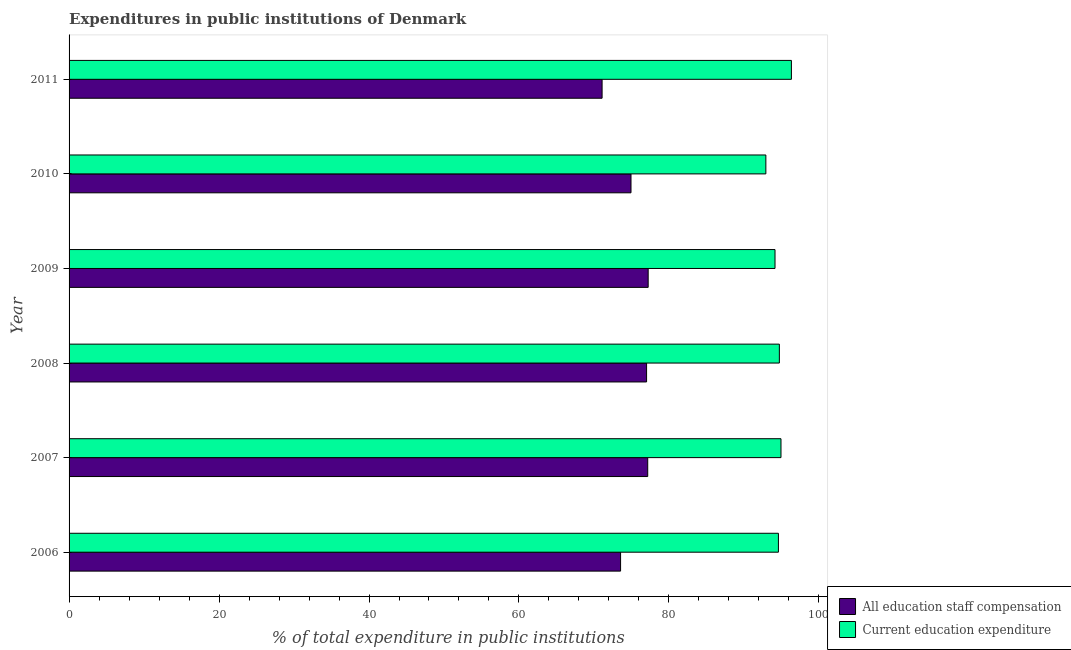How many different coloured bars are there?
Give a very brief answer. 2. How many groups of bars are there?
Provide a short and direct response. 6. How many bars are there on the 5th tick from the top?
Keep it short and to the point. 2. What is the label of the 5th group of bars from the top?
Give a very brief answer. 2007. What is the expenditure in staff compensation in 2008?
Offer a very short reply. 77.02. Across all years, what is the maximum expenditure in staff compensation?
Your response must be concise. 77.23. Across all years, what is the minimum expenditure in education?
Offer a terse response. 92.93. In which year was the expenditure in education maximum?
Provide a succinct answer. 2011. In which year was the expenditure in staff compensation minimum?
Ensure brevity in your answer.  2011. What is the total expenditure in staff compensation in the graph?
Offer a very short reply. 451. What is the difference between the expenditure in staff compensation in 2008 and that in 2010?
Your answer should be compact. 2.08. What is the difference between the expenditure in staff compensation in 2009 and the expenditure in education in 2010?
Offer a terse response. -15.69. What is the average expenditure in staff compensation per year?
Your answer should be very brief. 75.17. In the year 2006, what is the difference between the expenditure in education and expenditure in staff compensation?
Offer a terse response. 21.05. In how many years, is the expenditure in staff compensation greater than 96 %?
Your answer should be very brief. 0. What is the ratio of the expenditure in education in 2007 to that in 2009?
Your response must be concise. 1.01. What is the difference between the highest and the second highest expenditure in education?
Your answer should be compact. 1.39. What is the difference between the highest and the lowest expenditure in staff compensation?
Offer a very short reply. 6.15. Is the sum of the expenditure in education in 2007 and 2010 greater than the maximum expenditure in staff compensation across all years?
Your answer should be very brief. Yes. What does the 2nd bar from the top in 2008 represents?
Ensure brevity in your answer.  All education staff compensation. What does the 1st bar from the bottom in 2009 represents?
Your answer should be very brief. All education staff compensation. How many bars are there?
Offer a very short reply. 12. Are all the bars in the graph horizontal?
Provide a short and direct response. Yes. How many years are there in the graph?
Make the answer very short. 6. What is the difference between two consecutive major ticks on the X-axis?
Give a very brief answer. 20. Does the graph contain any zero values?
Your answer should be compact. No. Does the graph contain grids?
Ensure brevity in your answer.  No. How are the legend labels stacked?
Provide a short and direct response. Vertical. What is the title of the graph?
Your answer should be very brief. Expenditures in public institutions of Denmark. What is the label or title of the X-axis?
Your answer should be very brief. % of total expenditure in public institutions. What is the label or title of the Y-axis?
Provide a short and direct response. Year. What is the % of total expenditure in public institutions of All education staff compensation in 2006?
Ensure brevity in your answer.  73.55. What is the % of total expenditure in public institutions in Current education expenditure in 2006?
Your answer should be compact. 94.6. What is the % of total expenditure in public institutions of All education staff compensation in 2007?
Provide a short and direct response. 77.17. What is the % of total expenditure in public institutions in Current education expenditure in 2007?
Make the answer very short. 94.94. What is the % of total expenditure in public institutions in All education staff compensation in 2008?
Your answer should be compact. 77.02. What is the % of total expenditure in public institutions of Current education expenditure in 2008?
Provide a short and direct response. 94.73. What is the % of total expenditure in public institutions of All education staff compensation in 2009?
Keep it short and to the point. 77.23. What is the % of total expenditure in public institutions in Current education expenditure in 2009?
Keep it short and to the point. 94.15. What is the % of total expenditure in public institutions of All education staff compensation in 2010?
Offer a very short reply. 74.94. What is the % of total expenditure in public institutions in Current education expenditure in 2010?
Keep it short and to the point. 92.93. What is the % of total expenditure in public institutions in All education staff compensation in 2011?
Offer a terse response. 71.09. What is the % of total expenditure in public institutions of Current education expenditure in 2011?
Your response must be concise. 96.33. Across all years, what is the maximum % of total expenditure in public institutions of All education staff compensation?
Provide a succinct answer. 77.23. Across all years, what is the maximum % of total expenditure in public institutions of Current education expenditure?
Offer a terse response. 96.33. Across all years, what is the minimum % of total expenditure in public institutions in All education staff compensation?
Offer a terse response. 71.09. Across all years, what is the minimum % of total expenditure in public institutions of Current education expenditure?
Make the answer very short. 92.93. What is the total % of total expenditure in public institutions of All education staff compensation in the graph?
Make the answer very short. 451. What is the total % of total expenditure in public institutions of Current education expenditure in the graph?
Make the answer very short. 567.68. What is the difference between the % of total expenditure in public institutions of All education staff compensation in 2006 and that in 2007?
Your answer should be very brief. -3.62. What is the difference between the % of total expenditure in public institutions of Current education expenditure in 2006 and that in 2007?
Your answer should be very brief. -0.34. What is the difference between the % of total expenditure in public institutions of All education staff compensation in 2006 and that in 2008?
Provide a short and direct response. -3.47. What is the difference between the % of total expenditure in public institutions in Current education expenditure in 2006 and that in 2008?
Keep it short and to the point. -0.13. What is the difference between the % of total expenditure in public institutions of All education staff compensation in 2006 and that in 2009?
Your response must be concise. -3.68. What is the difference between the % of total expenditure in public institutions of Current education expenditure in 2006 and that in 2009?
Ensure brevity in your answer.  0.45. What is the difference between the % of total expenditure in public institutions of All education staff compensation in 2006 and that in 2010?
Provide a succinct answer. -1.39. What is the difference between the % of total expenditure in public institutions of Current education expenditure in 2006 and that in 2010?
Your answer should be very brief. 1.67. What is the difference between the % of total expenditure in public institutions of All education staff compensation in 2006 and that in 2011?
Your answer should be compact. 2.47. What is the difference between the % of total expenditure in public institutions in Current education expenditure in 2006 and that in 2011?
Offer a terse response. -1.73. What is the difference between the % of total expenditure in public institutions of All education staff compensation in 2007 and that in 2008?
Offer a very short reply. 0.15. What is the difference between the % of total expenditure in public institutions of Current education expenditure in 2007 and that in 2008?
Provide a succinct answer. 0.22. What is the difference between the % of total expenditure in public institutions in All education staff compensation in 2007 and that in 2009?
Keep it short and to the point. -0.06. What is the difference between the % of total expenditure in public institutions of Current education expenditure in 2007 and that in 2009?
Ensure brevity in your answer.  0.8. What is the difference between the % of total expenditure in public institutions of All education staff compensation in 2007 and that in 2010?
Your answer should be compact. 2.23. What is the difference between the % of total expenditure in public institutions in Current education expenditure in 2007 and that in 2010?
Provide a short and direct response. 2.02. What is the difference between the % of total expenditure in public institutions in All education staff compensation in 2007 and that in 2011?
Your answer should be compact. 6.08. What is the difference between the % of total expenditure in public institutions of Current education expenditure in 2007 and that in 2011?
Offer a very short reply. -1.39. What is the difference between the % of total expenditure in public institutions in All education staff compensation in 2008 and that in 2009?
Offer a terse response. -0.21. What is the difference between the % of total expenditure in public institutions of Current education expenditure in 2008 and that in 2009?
Your answer should be compact. 0.58. What is the difference between the % of total expenditure in public institutions of All education staff compensation in 2008 and that in 2010?
Offer a very short reply. 2.08. What is the difference between the % of total expenditure in public institutions in Current education expenditure in 2008 and that in 2010?
Offer a very short reply. 1.8. What is the difference between the % of total expenditure in public institutions of All education staff compensation in 2008 and that in 2011?
Offer a terse response. 5.93. What is the difference between the % of total expenditure in public institutions in Current education expenditure in 2008 and that in 2011?
Provide a short and direct response. -1.61. What is the difference between the % of total expenditure in public institutions of All education staff compensation in 2009 and that in 2010?
Make the answer very short. 2.29. What is the difference between the % of total expenditure in public institutions of Current education expenditure in 2009 and that in 2010?
Ensure brevity in your answer.  1.22. What is the difference between the % of total expenditure in public institutions in All education staff compensation in 2009 and that in 2011?
Give a very brief answer. 6.15. What is the difference between the % of total expenditure in public institutions in Current education expenditure in 2009 and that in 2011?
Offer a terse response. -2.19. What is the difference between the % of total expenditure in public institutions in All education staff compensation in 2010 and that in 2011?
Make the answer very short. 3.85. What is the difference between the % of total expenditure in public institutions in Current education expenditure in 2010 and that in 2011?
Make the answer very short. -3.41. What is the difference between the % of total expenditure in public institutions in All education staff compensation in 2006 and the % of total expenditure in public institutions in Current education expenditure in 2007?
Provide a short and direct response. -21.39. What is the difference between the % of total expenditure in public institutions in All education staff compensation in 2006 and the % of total expenditure in public institutions in Current education expenditure in 2008?
Keep it short and to the point. -21.18. What is the difference between the % of total expenditure in public institutions of All education staff compensation in 2006 and the % of total expenditure in public institutions of Current education expenditure in 2009?
Provide a short and direct response. -20.59. What is the difference between the % of total expenditure in public institutions in All education staff compensation in 2006 and the % of total expenditure in public institutions in Current education expenditure in 2010?
Provide a succinct answer. -19.37. What is the difference between the % of total expenditure in public institutions of All education staff compensation in 2006 and the % of total expenditure in public institutions of Current education expenditure in 2011?
Provide a short and direct response. -22.78. What is the difference between the % of total expenditure in public institutions of All education staff compensation in 2007 and the % of total expenditure in public institutions of Current education expenditure in 2008?
Offer a very short reply. -17.56. What is the difference between the % of total expenditure in public institutions in All education staff compensation in 2007 and the % of total expenditure in public institutions in Current education expenditure in 2009?
Your answer should be compact. -16.98. What is the difference between the % of total expenditure in public institutions in All education staff compensation in 2007 and the % of total expenditure in public institutions in Current education expenditure in 2010?
Ensure brevity in your answer.  -15.76. What is the difference between the % of total expenditure in public institutions in All education staff compensation in 2007 and the % of total expenditure in public institutions in Current education expenditure in 2011?
Make the answer very short. -19.16. What is the difference between the % of total expenditure in public institutions of All education staff compensation in 2008 and the % of total expenditure in public institutions of Current education expenditure in 2009?
Ensure brevity in your answer.  -17.13. What is the difference between the % of total expenditure in public institutions in All education staff compensation in 2008 and the % of total expenditure in public institutions in Current education expenditure in 2010?
Offer a very short reply. -15.91. What is the difference between the % of total expenditure in public institutions of All education staff compensation in 2008 and the % of total expenditure in public institutions of Current education expenditure in 2011?
Provide a succinct answer. -19.32. What is the difference between the % of total expenditure in public institutions in All education staff compensation in 2009 and the % of total expenditure in public institutions in Current education expenditure in 2010?
Offer a terse response. -15.69. What is the difference between the % of total expenditure in public institutions of All education staff compensation in 2009 and the % of total expenditure in public institutions of Current education expenditure in 2011?
Provide a short and direct response. -19.1. What is the difference between the % of total expenditure in public institutions of All education staff compensation in 2010 and the % of total expenditure in public institutions of Current education expenditure in 2011?
Ensure brevity in your answer.  -21.39. What is the average % of total expenditure in public institutions in All education staff compensation per year?
Your response must be concise. 75.17. What is the average % of total expenditure in public institutions in Current education expenditure per year?
Keep it short and to the point. 94.61. In the year 2006, what is the difference between the % of total expenditure in public institutions in All education staff compensation and % of total expenditure in public institutions in Current education expenditure?
Give a very brief answer. -21.05. In the year 2007, what is the difference between the % of total expenditure in public institutions of All education staff compensation and % of total expenditure in public institutions of Current education expenditure?
Provide a succinct answer. -17.77. In the year 2008, what is the difference between the % of total expenditure in public institutions in All education staff compensation and % of total expenditure in public institutions in Current education expenditure?
Offer a very short reply. -17.71. In the year 2009, what is the difference between the % of total expenditure in public institutions of All education staff compensation and % of total expenditure in public institutions of Current education expenditure?
Provide a succinct answer. -16.91. In the year 2010, what is the difference between the % of total expenditure in public institutions in All education staff compensation and % of total expenditure in public institutions in Current education expenditure?
Make the answer very short. -17.98. In the year 2011, what is the difference between the % of total expenditure in public institutions of All education staff compensation and % of total expenditure in public institutions of Current education expenditure?
Keep it short and to the point. -25.25. What is the ratio of the % of total expenditure in public institutions of All education staff compensation in 2006 to that in 2007?
Keep it short and to the point. 0.95. What is the ratio of the % of total expenditure in public institutions of Current education expenditure in 2006 to that in 2007?
Make the answer very short. 1. What is the ratio of the % of total expenditure in public institutions in All education staff compensation in 2006 to that in 2008?
Keep it short and to the point. 0.95. What is the ratio of the % of total expenditure in public institutions in All education staff compensation in 2006 to that in 2010?
Offer a terse response. 0.98. What is the ratio of the % of total expenditure in public institutions in All education staff compensation in 2006 to that in 2011?
Keep it short and to the point. 1.03. What is the ratio of the % of total expenditure in public institutions in Current education expenditure in 2006 to that in 2011?
Your response must be concise. 0.98. What is the ratio of the % of total expenditure in public institutions of Current education expenditure in 2007 to that in 2008?
Your answer should be very brief. 1. What is the ratio of the % of total expenditure in public institutions in Current education expenditure in 2007 to that in 2009?
Provide a short and direct response. 1.01. What is the ratio of the % of total expenditure in public institutions of All education staff compensation in 2007 to that in 2010?
Provide a short and direct response. 1.03. What is the ratio of the % of total expenditure in public institutions in Current education expenditure in 2007 to that in 2010?
Make the answer very short. 1.02. What is the ratio of the % of total expenditure in public institutions of All education staff compensation in 2007 to that in 2011?
Your answer should be compact. 1.09. What is the ratio of the % of total expenditure in public institutions in Current education expenditure in 2007 to that in 2011?
Offer a terse response. 0.99. What is the ratio of the % of total expenditure in public institutions of All education staff compensation in 2008 to that in 2009?
Ensure brevity in your answer.  1. What is the ratio of the % of total expenditure in public institutions in Current education expenditure in 2008 to that in 2009?
Provide a short and direct response. 1.01. What is the ratio of the % of total expenditure in public institutions in All education staff compensation in 2008 to that in 2010?
Offer a terse response. 1.03. What is the ratio of the % of total expenditure in public institutions of Current education expenditure in 2008 to that in 2010?
Make the answer very short. 1.02. What is the ratio of the % of total expenditure in public institutions of All education staff compensation in 2008 to that in 2011?
Your response must be concise. 1.08. What is the ratio of the % of total expenditure in public institutions in Current education expenditure in 2008 to that in 2011?
Your answer should be compact. 0.98. What is the ratio of the % of total expenditure in public institutions in All education staff compensation in 2009 to that in 2010?
Your answer should be very brief. 1.03. What is the ratio of the % of total expenditure in public institutions of Current education expenditure in 2009 to that in 2010?
Your response must be concise. 1.01. What is the ratio of the % of total expenditure in public institutions of All education staff compensation in 2009 to that in 2011?
Keep it short and to the point. 1.09. What is the ratio of the % of total expenditure in public institutions of Current education expenditure in 2009 to that in 2011?
Keep it short and to the point. 0.98. What is the ratio of the % of total expenditure in public institutions of All education staff compensation in 2010 to that in 2011?
Offer a very short reply. 1.05. What is the ratio of the % of total expenditure in public institutions of Current education expenditure in 2010 to that in 2011?
Your answer should be compact. 0.96. What is the difference between the highest and the second highest % of total expenditure in public institutions of All education staff compensation?
Provide a short and direct response. 0.06. What is the difference between the highest and the second highest % of total expenditure in public institutions of Current education expenditure?
Make the answer very short. 1.39. What is the difference between the highest and the lowest % of total expenditure in public institutions in All education staff compensation?
Give a very brief answer. 6.15. What is the difference between the highest and the lowest % of total expenditure in public institutions of Current education expenditure?
Your response must be concise. 3.41. 